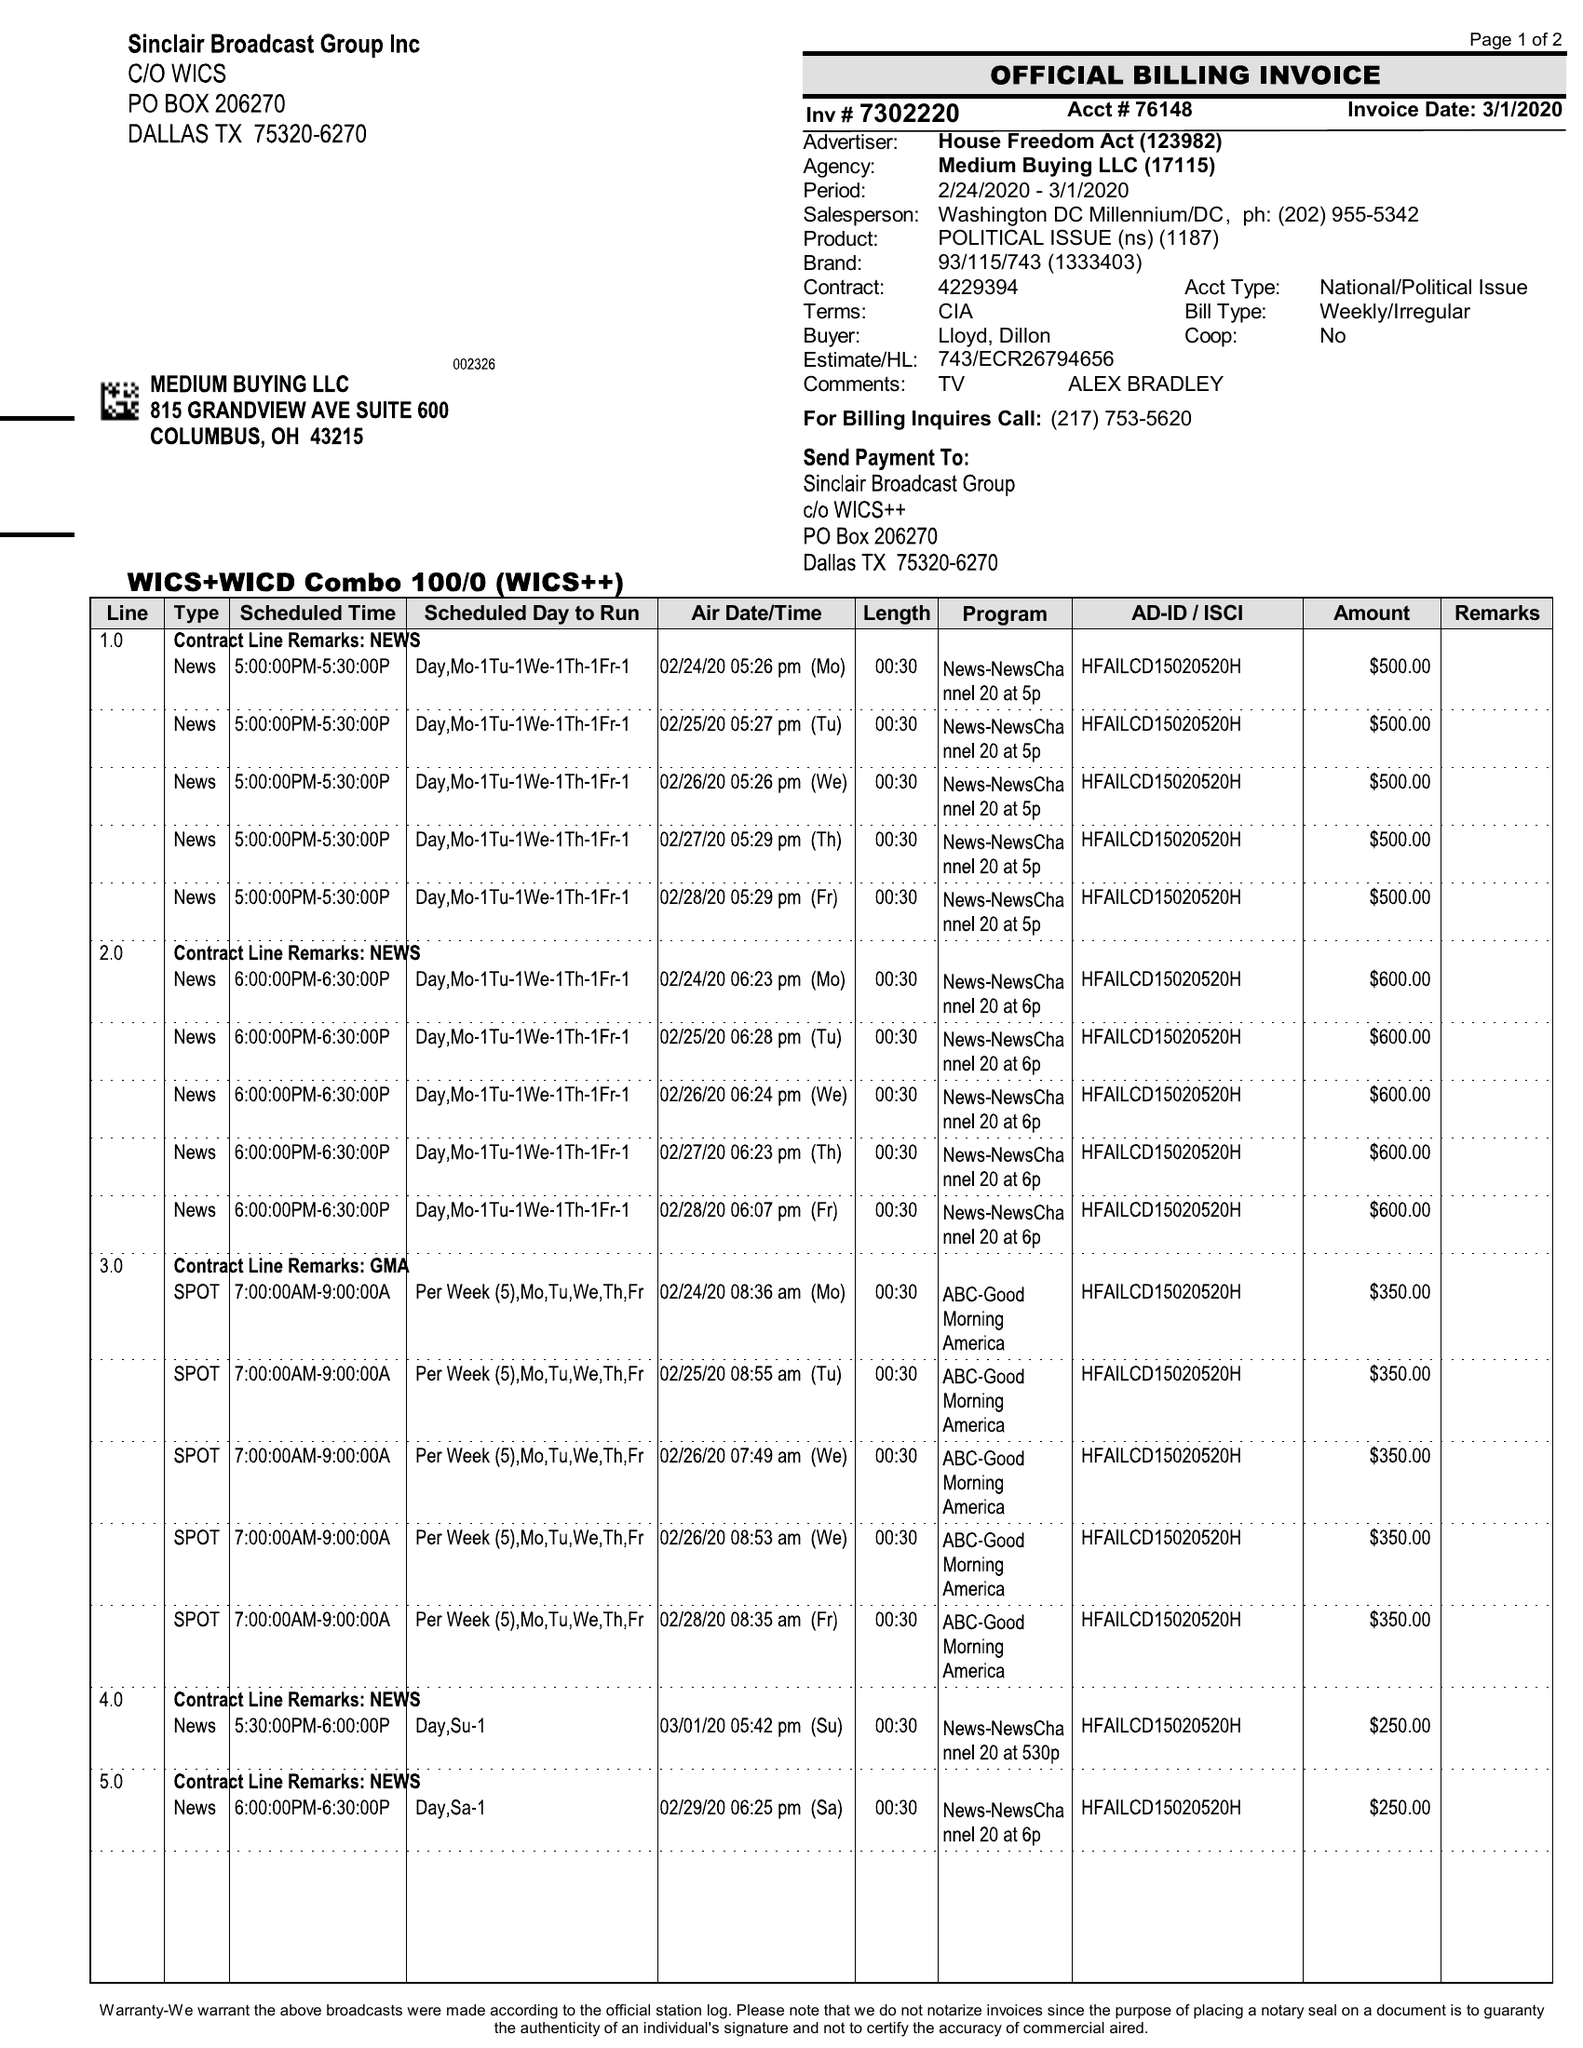What is the value for the gross_amount?
Answer the question using a single word or phrase. 7750.00 